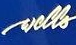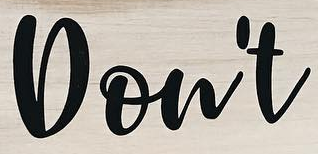What words are shown in these images in order, separated by a semicolon? wells; Don't 